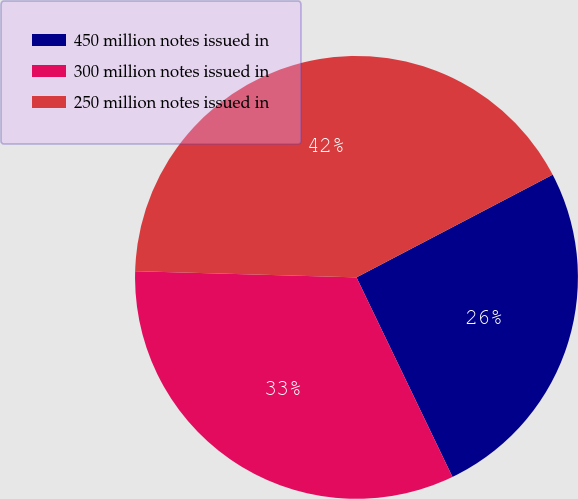Convert chart to OTSL. <chart><loc_0><loc_0><loc_500><loc_500><pie_chart><fcel>450 million notes issued in<fcel>300 million notes issued in<fcel>250 million notes issued in<nl><fcel>25.54%<fcel>32.58%<fcel>41.88%<nl></chart> 